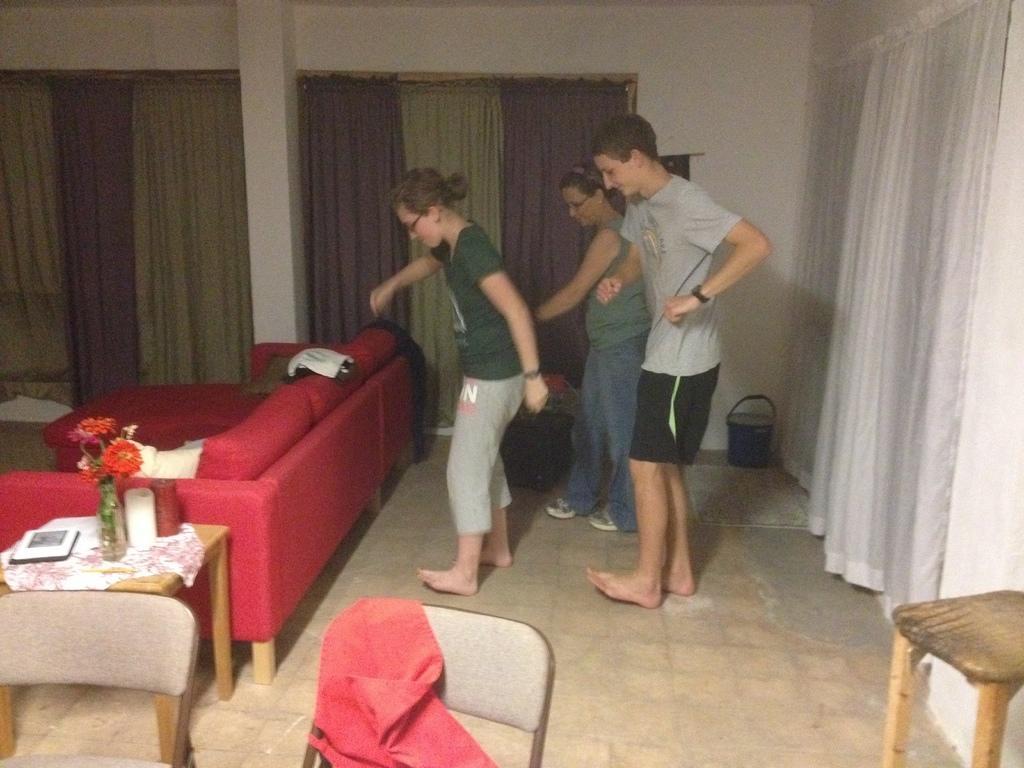Could you give a brief overview of what you see in this image? The image is clicked inside the house. In this image there are three persons, two women and one man. In the background there is a curtain and a wall along with pillar. In the front there is a chair, table and a red color sofa. It seems like this three persons are dancing. 